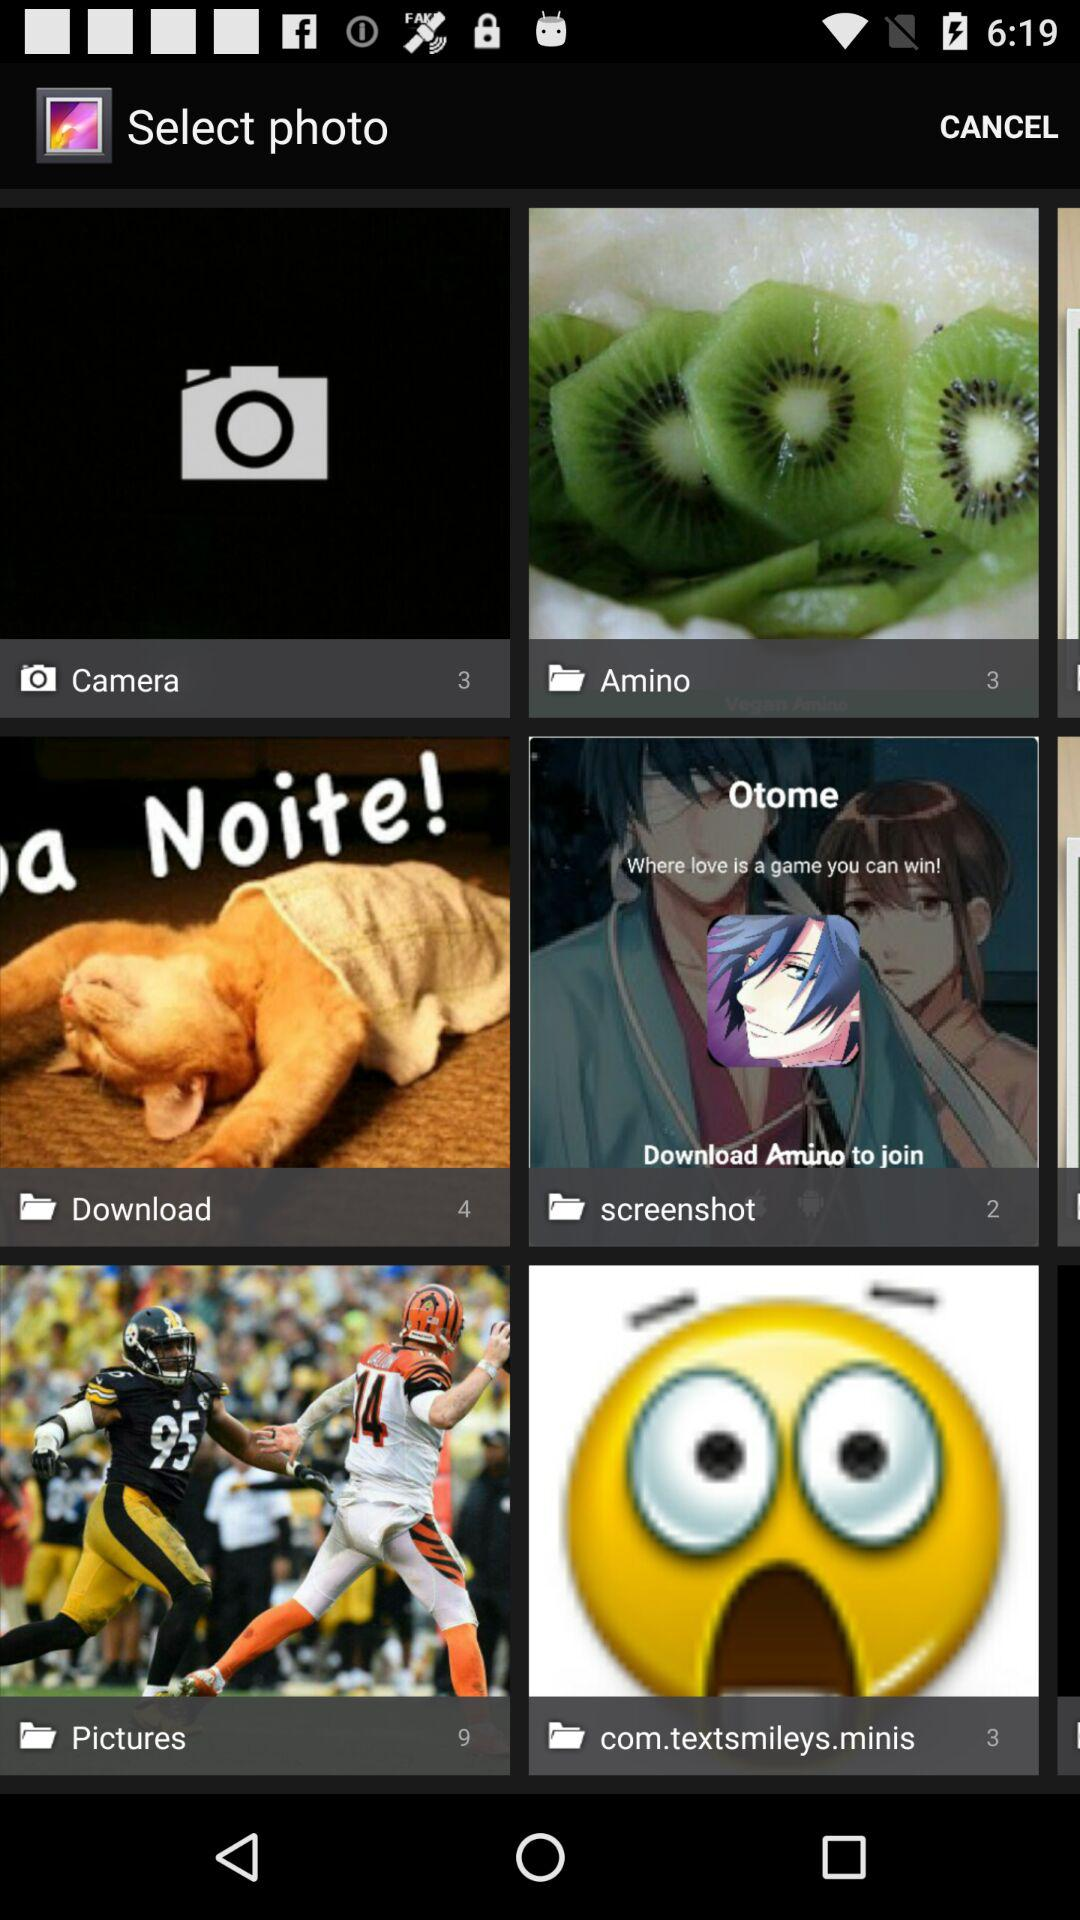How many photos are there in "Pictures"? There are 9 photos in "Pictures". 